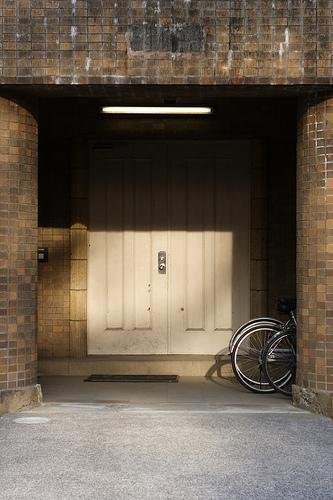How many bikes are there?
Give a very brief answer. 3. 